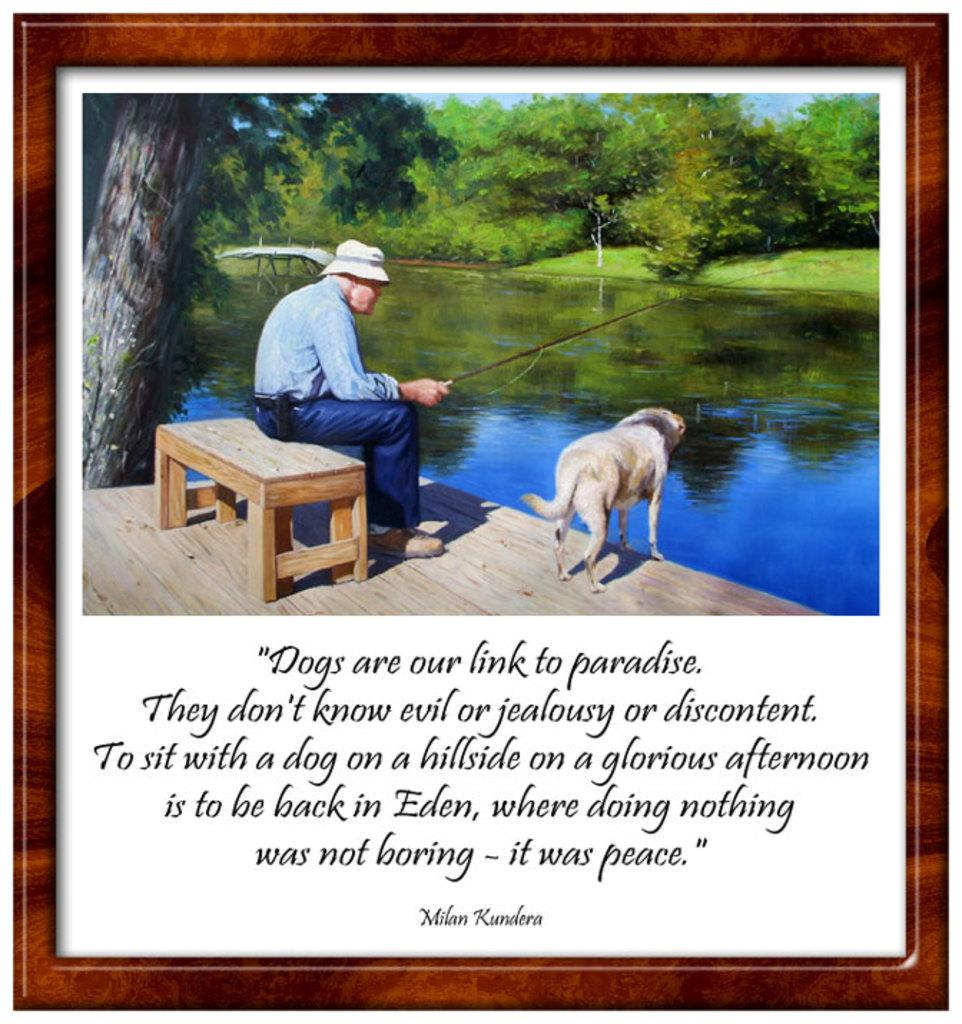<image>
Offer a succinct explanation of the picture presented. A photo of a man fishing with his dog and a quote below the picture by Milan Kundera 